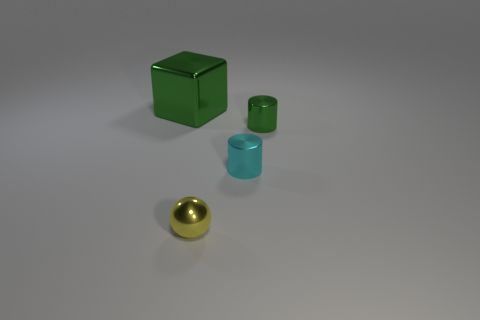Are there fewer small green objects that are to the left of the tiny cyan metallic thing than yellow balls that are behind the tiny yellow ball?
Your response must be concise. No. Is the shape of the tiny green object the same as the large shiny thing?
Your answer should be compact. No. What number of other things are the same size as the yellow ball?
Offer a very short reply. 2. How many objects are green things that are in front of the metallic cube or things in front of the big metallic cube?
Your answer should be compact. 3. What number of other large metallic objects are the same shape as the large metallic object?
Keep it short and to the point. 0. There is a small object that is both to the left of the small green metal cylinder and behind the yellow metal object; what material is it?
Your answer should be very brief. Metal. How many small yellow objects are on the right side of the yellow metallic sphere?
Your response must be concise. 0. What number of large red rubber objects are there?
Offer a very short reply. 0. Is the size of the yellow metallic thing the same as the cyan cylinder?
Give a very brief answer. Yes. There is a green metallic object that is in front of the shiny thing that is behind the small green cylinder; is there a tiny cyan thing that is on the left side of it?
Provide a short and direct response. Yes. 